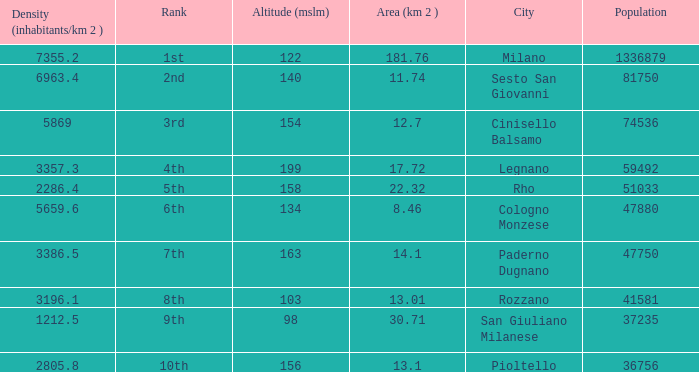Which Population has an Altitude (mslm) larger than 98, and a Density (inhabitants/km 2) larger than 5869, and a Rank of 1st? 1336879.0. 